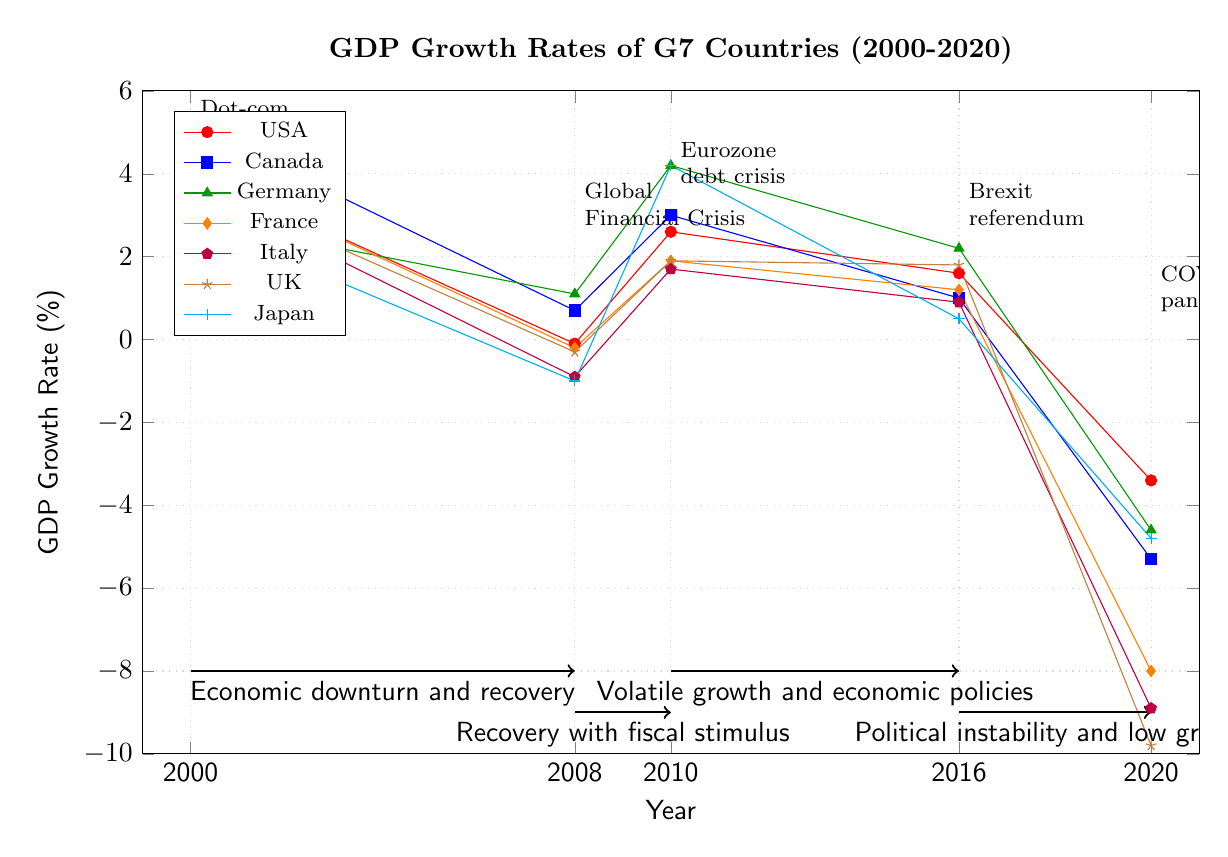What was the GDP growth rate for France in 2020? By locating France's line on the diagram, we see the coordinate for the year 2020 is set at -8.0.
Answer: -8.0 Which country had the highest GDP growth rate in 2000? The diagram displays the growth rates for each country in 2000, and Canada has the highest value at 5.2.
Answer: Canada What event is marked in 2008? The annotation on the diagram clearly states that the Global Financial Crisis occurred in 2008.
Answer: Global Financial Crisis Which country experienced the lowest GDP growth rate in 2020? By reviewing the growth rates in 2020, the UK has the lowest rate at -9.8 according to the plotted coordinates.
Answer: UK What is the trend of GDP growth rates across G7 countries from 2008 to 2010? The diagram indicates a recovery with fiscal stimulus from the low growth rate in 2008 (-0.1 for the USA) leading to higher rates in 2010, illustrating a positive trend across multiple countries.
Answer: Recovery Which year saw the highest GDP growth rate for Germany? According to the data presented, in 2010, Germany’s GDP growth rate peaked at 4.2, marking its highest point in the period covered.
Answer: 2010 How did the GDP growth rate of Italy change from 2008 to 2010? The diagram shows Italy's growth rate transitioning from -0.9 in 2008 to 1.7 in 2010, indicating recovery and improvement during that period.
Answer: Increased What is the economic event associated with the year 2016? The annotation on the diagram explicitly refers to the Brexit referendum as the major event that occurred in 2016.
Answer: Brexit referendum Which country had a negative GDP growth rate in 2016? Reviewing the plotted lines, it is evident that Italy and Japan both had negative growth rates in 2016, with Italy at 0.9 and Japan at 0.5.
Answer: Italy and Japan What general pattern can be observed from 2016 to 2020 during the COVID-19 pandemic? The diagram reveals a decline in GDP growth rates across all G7 countries, culminating in negative rates in 2020, indicating a trend of decreasing economic performance due to the pandemic.
Answer: Decline 